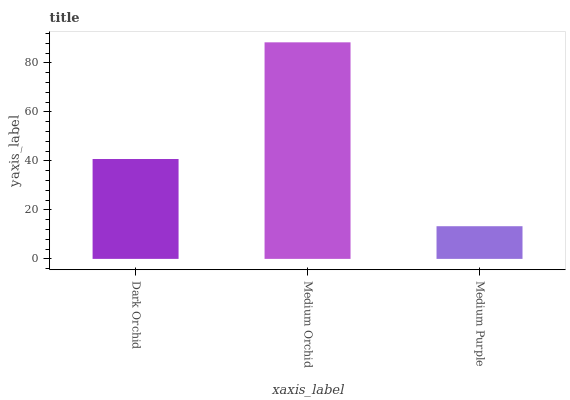Is Medium Purple the minimum?
Answer yes or no. Yes. Is Medium Orchid the maximum?
Answer yes or no. Yes. Is Medium Orchid the minimum?
Answer yes or no. No. Is Medium Purple the maximum?
Answer yes or no. No. Is Medium Orchid greater than Medium Purple?
Answer yes or no. Yes. Is Medium Purple less than Medium Orchid?
Answer yes or no. Yes. Is Medium Purple greater than Medium Orchid?
Answer yes or no. No. Is Medium Orchid less than Medium Purple?
Answer yes or no. No. Is Dark Orchid the high median?
Answer yes or no. Yes. Is Dark Orchid the low median?
Answer yes or no. Yes. Is Medium Orchid the high median?
Answer yes or no. No. Is Medium Orchid the low median?
Answer yes or no. No. 